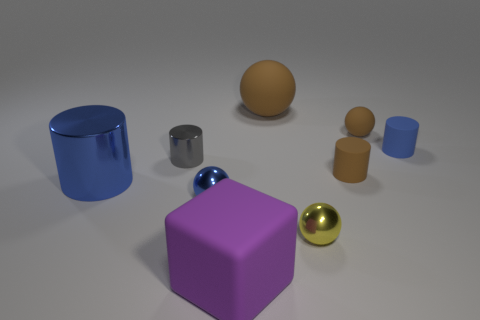How many tiny things are both in front of the small gray metallic cylinder and to the left of the tiny brown cylinder?
Your response must be concise. 2. There is a matte ball that is on the right side of the yellow thing; is its size the same as the metal object that is behind the big blue metal cylinder?
Ensure brevity in your answer.  Yes. What number of things are either blue objects that are left of the gray cylinder or purple objects?
Offer a very short reply. 2. There is a brown ball to the right of the tiny brown matte cylinder; what is it made of?
Ensure brevity in your answer.  Rubber. What is the material of the tiny gray thing?
Provide a succinct answer. Metal. There is a blue object to the right of the large matte object that is to the left of the brown rubber ball to the left of the small yellow sphere; what is its material?
Make the answer very short. Rubber. Is there any other thing that is the same material as the brown cylinder?
Provide a succinct answer. Yes. Do the matte block and the metal ball to the left of the matte block have the same size?
Offer a terse response. No. How many objects are either matte things that are in front of the tiny yellow sphere or matte objects in front of the large brown matte ball?
Keep it short and to the point. 4. There is a metal sphere to the left of the big matte sphere; what is its color?
Make the answer very short. Blue. 